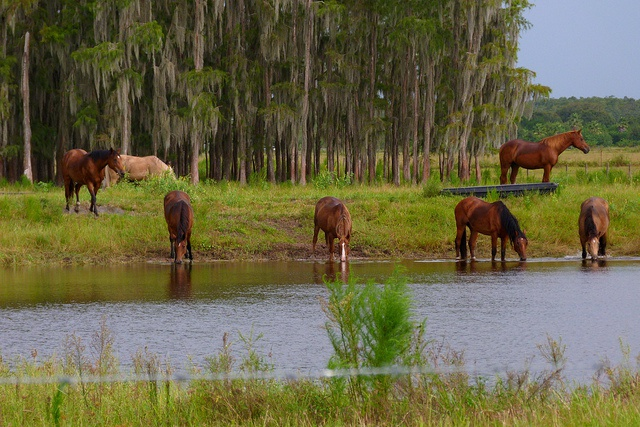Describe the objects in this image and their specific colors. I can see horse in black, maroon, olive, and brown tones, horse in black, maroon, brown, and olive tones, horse in black, maroon, olive, and brown tones, horse in black, maroon, olive, and brown tones, and horse in black, maroon, and brown tones in this image. 